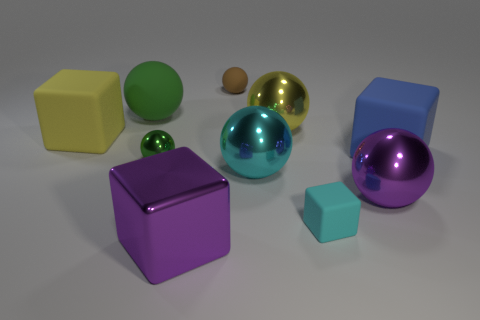Is the color of the tiny rubber block the same as the tiny metallic thing?
Ensure brevity in your answer.  No. What number of big balls have the same color as the small metallic ball?
Offer a very short reply. 1. Is there a big cyan metallic thing that is on the right side of the tiny matte object that is in front of the matte block on the right side of the small cyan matte block?
Your answer should be compact. No. The green rubber thing that is the same size as the blue block is what shape?
Give a very brief answer. Sphere. How many tiny objects are either cyan spheres or metallic blocks?
Your answer should be compact. 0. There is a small ball that is made of the same material as the tiny block; what color is it?
Ensure brevity in your answer.  Brown. Does the purple metal thing that is behind the purple block have the same shape as the thing that is behind the big green thing?
Offer a very short reply. Yes. How many rubber objects are either small things or big green objects?
Provide a succinct answer. 3. What material is the other object that is the same color as the tiny shiny thing?
Ensure brevity in your answer.  Rubber. What is the material of the yellow thing in front of the large yellow metal thing?
Give a very brief answer. Rubber. 